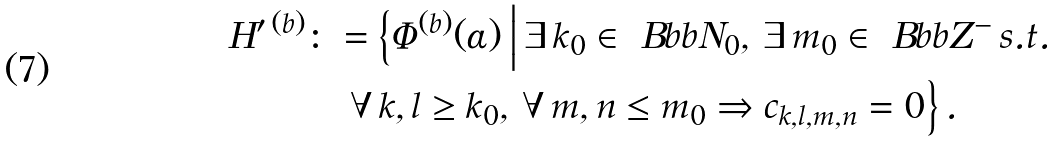<formula> <loc_0><loc_0><loc_500><loc_500>H ^ { \prime \, ( b ) } & \colon = \Big \{ \varPhi ^ { ( b ) } ( \alpha ) \, \Big | \, \exists \, k _ { 0 } \in \ B b b { N } _ { 0 } , \, \exists \, m _ { 0 } \in \ B b b { Z } ^ { - } \, s . t . \\ & \quad \, \forall \, k , l \geq k _ { 0 } , \, \forall \, m , n \leq m _ { 0 } \Rightarrow c _ { k , l , m , n } = 0 \Big \} \, .</formula> 